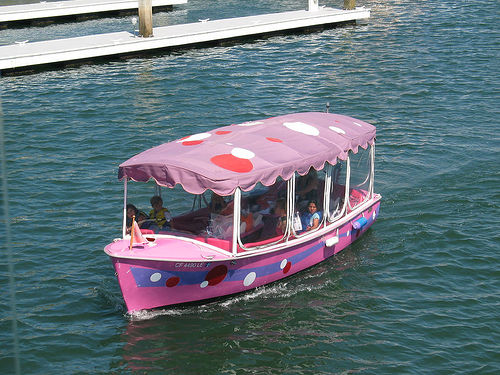Could you tell me more about the setting of this picture? The image shows a vibrant and playful boat cruising through calm waters, likely a lake or a slow-moving river. The setting seems to be recreational, possibly a theme park or tourist attraction, suggested by the unique design of the boat. The docks in the background hint at an organized operation, with other similar boats likely nearby, ready to offer unique experiences to visitors. 